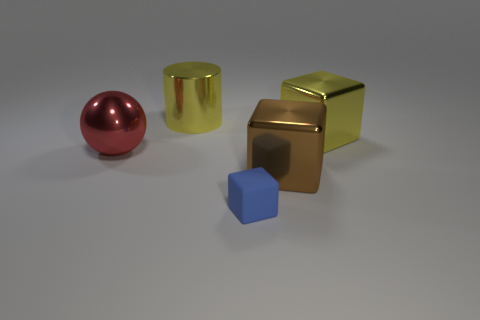Subtract all rubber cubes. How many cubes are left? 2 Add 1 balls. How many objects exist? 6 Subtract all balls. How many objects are left? 4 Add 4 metallic objects. How many metallic objects exist? 8 Subtract 0 purple balls. How many objects are left? 5 Subtract 1 spheres. How many spheres are left? 0 Subtract all blue cylinders. Subtract all brown balls. How many cylinders are left? 1 Subtract all tiny gray shiny cylinders. Subtract all blue cubes. How many objects are left? 4 Add 1 big yellow things. How many big yellow things are left? 3 